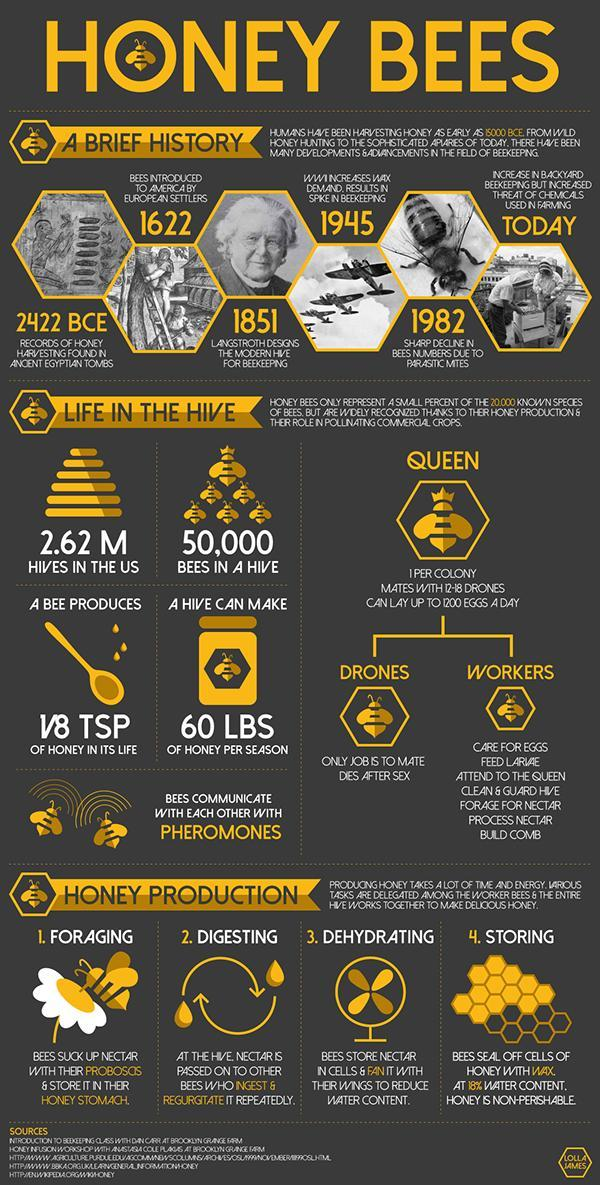When was a sharp decline seen in bees numbers due to parasitic mites?
Answer the question with a short phrase. 1982 How many bees can live in a hive? 50,000 When did Langstroth designed the modern hive for beekeeping? 1851 How much honey does a bee hive produce per season? 60 LBS How much honey does a bee produce in its life? 1/8 TSP How many hives were found in the US? 2.62 M When was the records of honey harvesting found in ancient Egyptian tombs? 2422 BCE 